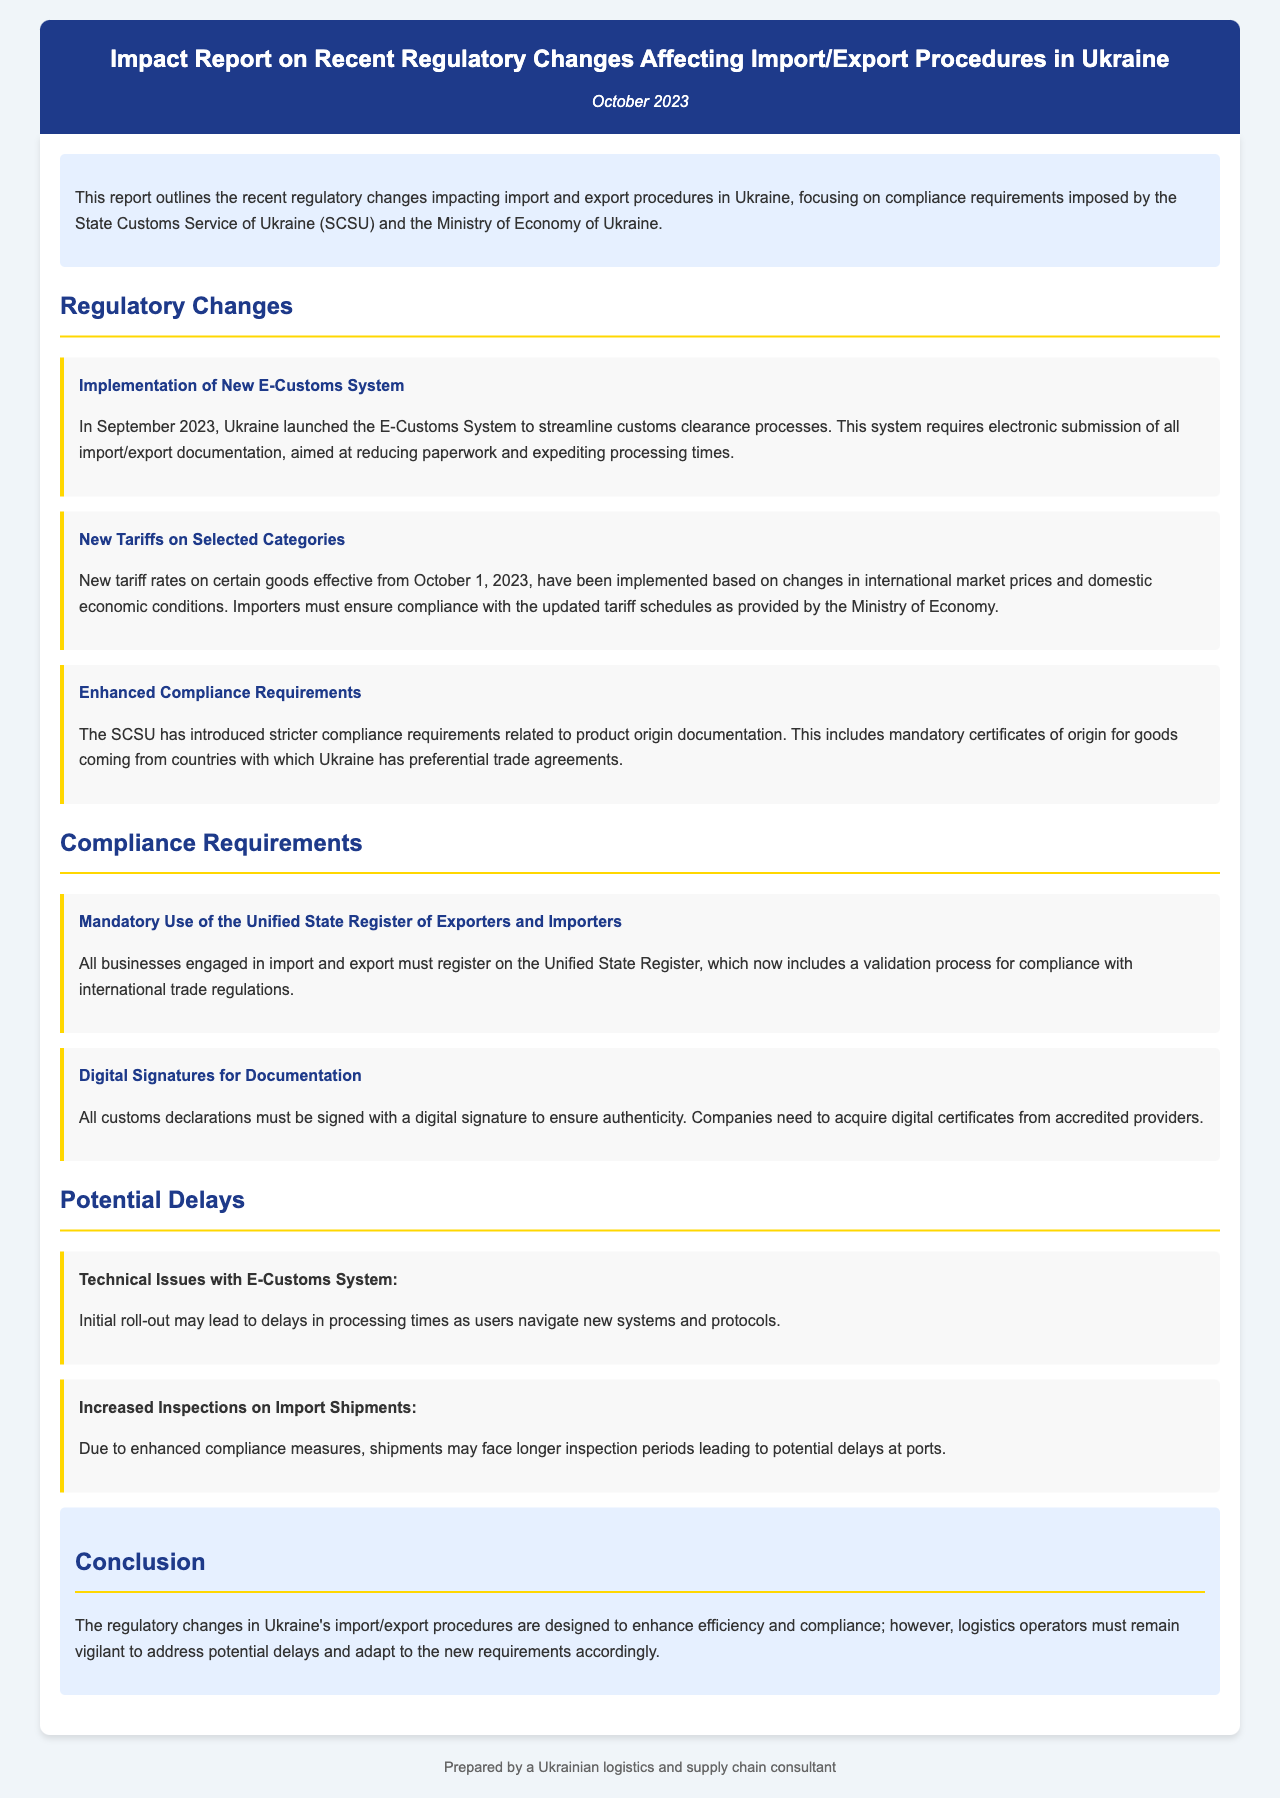what is the title of the report? The title of the report is stated in the header section of the document.
Answer: Impact Report on Recent Regulatory Changes Affecting Import/Export Procedures in Ukraine when was the E-Customs System launched? The launch date of the E-Customs System is mentioned under the Regulatory Changes section.
Answer: September 2023 what major compliance requirement involves digital signatures? This requirement is specifically noted under the Compliance Requirements section of the document.
Answer: Digital Signatures for Documentation what type of goods have new tariff rates effective October 1, 2023? The document specifies that tariff rates have been implemented on certain goods.
Answer: Selected Categories what is one potential delay mentioned due to the new regulations? The document lists potential delays in the Potential Delays section.
Answer: Increased Inspections on Import Shipments how many mandatory compliance requirements are listed in the report? The Compliance Requirements section contains two specific requirements mentioned.
Answer: Two 